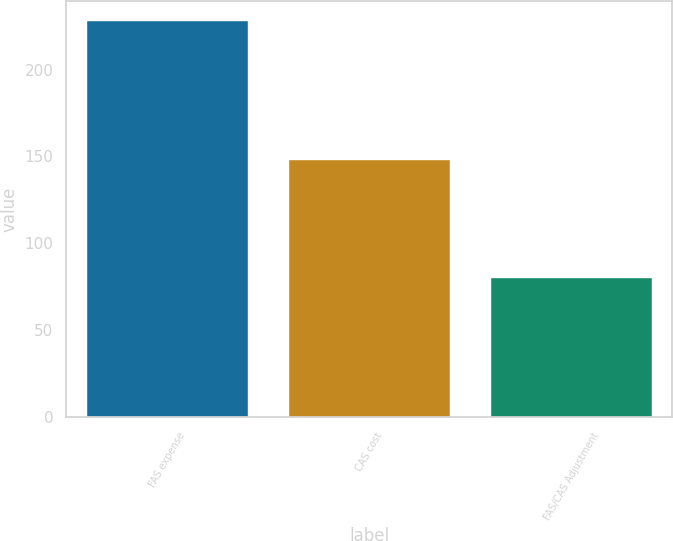<chart> <loc_0><loc_0><loc_500><loc_500><bar_chart><fcel>FAS expense<fcel>CAS cost<fcel>FAS/CAS Adjustment<nl><fcel>228<fcel>148<fcel>80<nl></chart> 